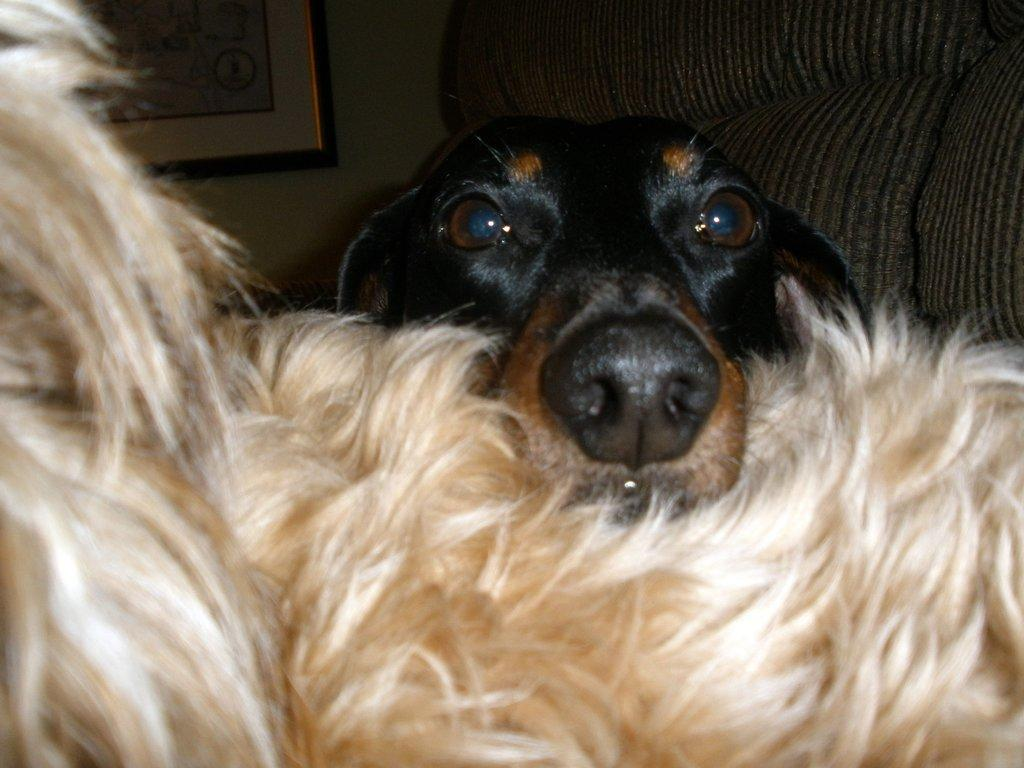What type of structure can be seen in the image? There is a wall in the image. Are there any objects hanging on the wall? Yes, there is a photo frame in the image. What type of furniture is present in the image? There is a sofa in the image. How many dogs are in the image? There are two dogs in the image. Where is one of the dogs located? One of the dogs is on the right side. What color is the dog on the right side? The dog on the right side is black. How would you describe the lighting in the image? The image is a little dark. What type of secretary can be seen working in the image? There is no secretary present in the image. Is there a gate visible in the image? There is no gate visible in the image. 